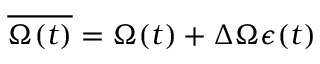Convert formula to latex. <formula><loc_0><loc_0><loc_500><loc_500>\overline { \Omega ( t ) } = \Omega ( t ) + \Delta \Omega \epsilon ( t )</formula> 